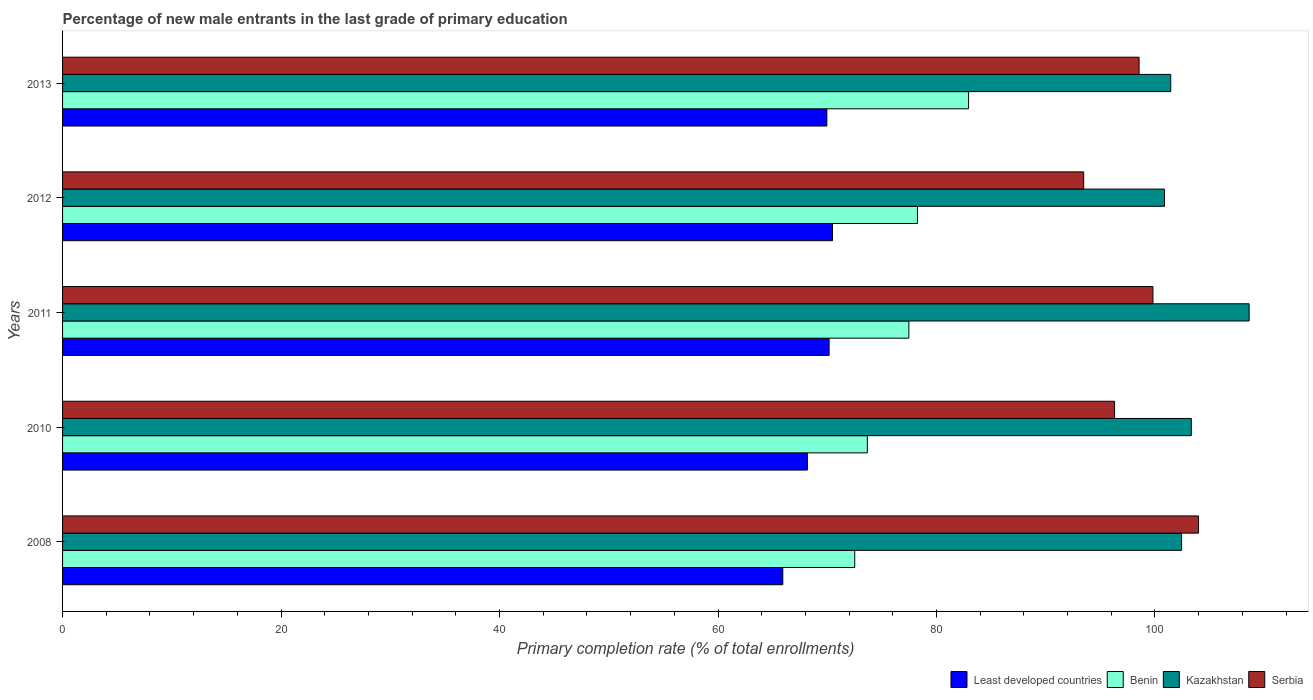Are the number of bars on each tick of the Y-axis equal?
Make the answer very short. Yes. What is the label of the 4th group of bars from the top?
Provide a succinct answer. 2010. What is the percentage of new male entrants in Kazakhstan in 2013?
Ensure brevity in your answer.  101.44. Across all years, what is the maximum percentage of new male entrants in Serbia?
Offer a very short reply. 103.99. Across all years, what is the minimum percentage of new male entrants in Kazakhstan?
Your answer should be very brief. 100.87. In which year was the percentage of new male entrants in Serbia minimum?
Keep it short and to the point. 2012. What is the total percentage of new male entrants in Least developed countries in the graph?
Ensure brevity in your answer.  344.72. What is the difference between the percentage of new male entrants in Kazakhstan in 2008 and that in 2013?
Offer a very short reply. 0.99. What is the difference between the percentage of new male entrants in Kazakhstan in 2010 and the percentage of new male entrants in Least developed countries in 2012?
Keep it short and to the point. 32.85. What is the average percentage of new male entrants in Kazakhstan per year?
Your response must be concise. 103.34. In the year 2011, what is the difference between the percentage of new male entrants in Kazakhstan and percentage of new male entrants in Benin?
Offer a terse response. 31.15. In how many years, is the percentage of new male entrants in Kazakhstan greater than 16 %?
Offer a very short reply. 5. What is the ratio of the percentage of new male entrants in Kazakhstan in 2010 to that in 2012?
Offer a very short reply. 1.02. Is the percentage of new male entrants in Benin in 2011 less than that in 2012?
Offer a terse response. Yes. Is the difference between the percentage of new male entrants in Kazakhstan in 2010 and 2012 greater than the difference between the percentage of new male entrants in Benin in 2010 and 2012?
Ensure brevity in your answer.  Yes. What is the difference between the highest and the second highest percentage of new male entrants in Serbia?
Offer a very short reply. 4.17. What is the difference between the highest and the lowest percentage of new male entrants in Serbia?
Ensure brevity in your answer.  10.51. What does the 3rd bar from the top in 2011 represents?
Provide a succinct answer. Benin. What does the 2nd bar from the bottom in 2010 represents?
Provide a succinct answer. Benin. Is it the case that in every year, the sum of the percentage of new male entrants in Benin and percentage of new male entrants in Kazakhstan is greater than the percentage of new male entrants in Serbia?
Make the answer very short. Yes. Are all the bars in the graph horizontal?
Keep it short and to the point. Yes. How many years are there in the graph?
Provide a short and direct response. 5. What is the difference between two consecutive major ticks on the X-axis?
Make the answer very short. 20. How many legend labels are there?
Your response must be concise. 4. What is the title of the graph?
Give a very brief answer. Percentage of new male entrants in the last grade of primary education. Does "Solomon Islands" appear as one of the legend labels in the graph?
Give a very brief answer. No. What is the label or title of the X-axis?
Your answer should be compact. Primary completion rate (% of total enrollments). What is the label or title of the Y-axis?
Give a very brief answer. Years. What is the Primary completion rate (% of total enrollments) of Least developed countries in 2008?
Your answer should be compact. 65.93. What is the Primary completion rate (% of total enrollments) of Benin in 2008?
Your response must be concise. 72.52. What is the Primary completion rate (% of total enrollments) of Kazakhstan in 2008?
Offer a terse response. 102.44. What is the Primary completion rate (% of total enrollments) of Serbia in 2008?
Provide a succinct answer. 103.99. What is the Primary completion rate (% of total enrollments) of Least developed countries in 2010?
Your answer should be compact. 68.18. What is the Primary completion rate (% of total enrollments) of Benin in 2010?
Your response must be concise. 73.67. What is the Primary completion rate (% of total enrollments) of Kazakhstan in 2010?
Offer a terse response. 103.33. What is the Primary completion rate (% of total enrollments) in Serbia in 2010?
Your response must be concise. 96.3. What is the Primary completion rate (% of total enrollments) in Least developed countries in 2011?
Your answer should be very brief. 70.17. What is the Primary completion rate (% of total enrollments) in Benin in 2011?
Ensure brevity in your answer.  77.47. What is the Primary completion rate (% of total enrollments) in Kazakhstan in 2011?
Offer a very short reply. 108.62. What is the Primary completion rate (% of total enrollments) of Serbia in 2011?
Offer a terse response. 99.81. What is the Primary completion rate (% of total enrollments) of Least developed countries in 2012?
Offer a terse response. 70.48. What is the Primary completion rate (% of total enrollments) in Benin in 2012?
Give a very brief answer. 78.26. What is the Primary completion rate (% of total enrollments) in Kazakhstan in 2012?
Ensure brevity in your answer.  100.87. What is the Primary completion rate (% of total enrollments) in Serbia in 2012?
Ensure brevity in your answer.  93.47. What is the Primary completion rate (% of total enrollments) in Least developed countries in 2013?
Offer a terse response. 69.96. What is the Primary completion rate (% of total enrollments) in Benin in 2013?
Your answer should be compact. 82.94. What is the Primary completion rate (% of total enrollments) of Kazakhstan in 2013?
Keep it short and to the point. 101.44. What is the Primary completion rate (% of total enrollments) in Serbia in 2013?
Give a very brief answer. 98.54. Across all years, what is the maximum Primary completion rate (% of total enrollments) of Least developed countries?
Ensure brevity in your answer.  70.48. Across all years, what is the maximum Primary completion rate (% of total enrollments) in Benin?
Give a very brief answer. 82.94. Across all years, what is the maximum Primary completion rate (% of total enrollments) in Kazakhstan?
Give a very brief answer. 108.62. Across all years, what is the maximum Primary completion rate (% of total enrollments) of Serbia?
Ensure brevity in your answer.  103.99. Across all years, what is the minimum Primary completion rate (% of total enrollments) of Least developed countries?
Your response must be concise. 65.93. Across all years, what is the minimum Primary completion rate (% of total enrollments) of Benin?
Provide a short and direct response. 72.52. Across all years, what is the minimum Primary completion rate (% of total enrollments) of Kazakhstan?
Your answer should be compact. 100.87. Across all years, what is the minimum Primary completion rate (% of total enrollments) in Serbia?
Your answer should be compact. 93.47. What is the total Primary completion rate (% of total enrollments) of Least developed countries in the graph?
Provide a succinct answer. 344.72. What is the total Primary completion rate (% of total enrollments) in Benin in the graph?
Ensure brevity in your answer.  384.85. What is the total Primary completion rate (% of total enrollments) of Kazakhstan in the graph?
Provide a succinct answer. 516.7. What is the total Primary completion rate (% of total enrollments) of Serbia in the graph?
Provide a succinct answer. 492.12. What is the difference between the Primary completion rate (% of total enrollments) of Least developed countries in 2008 and that in 2010?
Keep it short and to the point. -2.25. What is the difference between the Primary completion rate (% of total enrollments) in Benin in 2008 and that in 2010?
Provide a short and direct response. -1.15. What is the difference between the Primary completion rate (% of total enrollments) in Kazakhstan in 2008 and that in 2010?
Provide a succinct answer. -0.89. What is the difference between the Primary completion rate (% of total enrollments) in Serbia in 2008 and that in 2010?
Provide a succinct answer. 7.68. What is the difference between the Primary completion rate (% of total enrollments) of Least developed countries in 2008 and that in 2011?
Make the answer very short. -4.24. What is the difference between the Primary completion rate (% of total enrollments) of Benin in 2008 and that in 2011?
Your answer should be very brief. -4.96. What is the difference between the Primary completion rate (% of total enrollments) of Kazakhstan in 2008 and that in 2011?
Offer a terse response. -6.18. What is the difference between the Primary completion rate (% of total enrollments) in Serbia in 2008 and that in 2011?
Provide a short and direct response. 4.17. What is the difference between the Primary completion rate (% of total enrollments) of Least developed countries in 2008 and that in 2012?
Keep it short and to the point. -4.55. What is the difference between the Primary completion rate (% of total enrollments) of Benin in 2008 and that in 2012?
Offer a very short reply. -5.74. What is the difference between the Primary completion rate (% of total enrollments) in Kazakhstan in 2008 and that in 2012?
Your answer should be very brief. 1.56. What is the difference between the Primary completion rate (% of total enrollments) of Serbia in 2008 and that in 2012?
Provide a succinct answer. 10.51. What is the difference between the Primary completion rate (% of total enrollments) in Least developed countries in 2008 and that in 2013?
Keep it short and to the point. -4.03. What is the difference between the Primary completion rate (% of total enrollments) in Benin in 2008 and that in 2013?
Your answer should be very brief. -10.42. What is the difference between the Primary completion rate (% of total enrollments) in Kazakhstan in 2008 and that in 2013?
Make the answer very short. 0.99. What is the difference between the Primary completion rate (% of total enrollments) in Serbia in 2008 and that in 2013?
Give a very brief answer. 5.44. What is the difference between the Primary completion rate (% of total enrollments) in Least developed countries in 2010 and that in 2011?
Offer a very short reply. -1.99. What is the difference between the Primary completion rate (% of total enrollments) in Benin in 2010 and that in 2011?
Provide a succinct answer. -3.8. What is the difference between the Primary completion rate (% of total enrollments) in Kazakhstan in 2010 and that in 2011?
Make the answer very short. -5.29. What is the difference between the Primary completion rate (% of total enrollments) in Serbia in 2010 and that in 2011?
Keep it short and to the point. -3.51. What is the difference between the Primary completion rate (% of total enrollments) of Least developed countries in 2010 and that in 2012?
Make the answer very short. -2.3. What is the difference between the Primary completion rate (% of total enrollments) of Benin in 2010 and that in 2012?
Provide a succinct answer. -4.59. What is the difference between the Primary completion rate (% of total enrollments) in Kazakhstan in 2010 and that in 2012?
Make the answer very short. 2.46. What is the difference between the Primary completion rate (% of total enrollments) in Serbia in 2010 and that in 2012?
Provide a succinct answer. 2.83. What is the difference between the Primary completion rate (% of total enrollments) in Least developed countries in 2010 and that in 2013?
Provide a short and direct response. -1.78. What is the difference between the Primary completion rate (% of total enrollments) of Benin in 2010 and that in 2013?
Offer a terse response. -9.27. What is the difference between the Primary completion rate (% of total enrollments) of Kazakhstan in 2010 and that in 2013?
Your response must be concise. 1.88. What is the difference between the Primary completion rate (% of total enrollments) in Serbia in 2010 and that in 2013?
Offer a terse response. -2.24. What is the difference between the Primary completion rate (% of total enrollments) in Least developed countries in 2011 and that in 2012?
Keep it short and to the point. -0.31. What is the difference between the Primary completion rate (% of total enrollments) in Benin in 2011 and that in 2012?
Your response must be concise. -0.79. What is the difference between the Primary completion rate (% of total enrollments) in Kazakhstan in 2011 and that in 2012?
Offer a terse response. 7.75. What is the difference between the Primary completion rate (% of total enrollments) in Serbia in 2011 and that in 2012?
Ensure brevity in your answer.  6.34. What is the difference between the Primary completion rate (% of total enrollments) of Least developed countries in 2011 and that in 2013?
Keep it short and to the point. 0.21. What is the difference between the Primary completion rate (% of total enrollments) of Benin in 2011 and that in 2013?
Ensure brevity in your answer.  -5.46. What is the difference between the Primary completion rate (% of total enrollments) of Kazakhstan in 2011 and that in 2013?
Your response must be concise. 7.18. What is the difference between the Primary completion rate (% of total enrollments) in Serbia in 2011 and that in 2013?
Provide a short and direct response. 1.27. What is the difference between the Primary completion rate (% of total enrollments) in Least developed countries in 2012 and that in 2013?
Give a very brief answer. 0.52. What is the difference between the Primary completion rate (% of total enrollments) in Benin in 2012 and that in 2013?
Give a very brief answer. -4.68. What is the difference between the Primary completion rate (% of total enrollments) of Kazakhstan in 2012 and that in 2013?
Your response must be concise. -0.57. What is the difference between the Primary completion rate (% of total enrollments) of Serbia in 2012 and that in 2013?
Provide a short and direct response. -5.07. What is the difference between the Primary completion rate (% of total enrollments) in Least developed countries in 2008 and the Primary completion rate (% of total enrollments) in Benin in 2010?
Provide a short and direct response. -7.74. What is the difference between the Primary completion rate (% of total enrollments) in Least developed countries in 2008 and the Primary completion rate (% of total enrollments) in Kazakhstan in 2010?
Make the answer very short. -37.4. What is the difference between the Primary completion rate (% of total enrollments) of Least developed countries in 2008 and the Primary completion rate (% of total enrollments) of Serbia in 2010?
Your response must be concise. -30.37. What is the difference between the Primary completion rate (% of total enrollments) in Benin in 2008 and the Primary completion rate (% of total enrollments) in Kazakhstan in 2010?
Your answer should be compact. -30.81. What is the difference between the Primary completion rate (% of total enrollments) of Benin in 2008 and the Primary completion rate (% of total enrollments) of Serbia in 2010?
Make the answer very short. -23.79. What is the difference between the Primary completion rate (% of total enrollments) of Kazakhstan in 2008 and the Primary completion rate (% of total enrollments) of Serbia in 2010?
Ensure brevity in your answer.  6.13. What is the difference between the Primary completion rate (% of total enrollments) of Least developed countries in 2008 and the Primary completion rate (% of total enrollments) of Benin in 2011?
Give a very brief answer. -11.54. What is the difference between the Primary completion rate (% of total enrollments) in Least developed countries in 2008 and the Primary completion rate (% of total enrollments) in Kazakhstan in 2011?
Make the answer very short. -42.69. What is the difference between the Primary completion rate (% of total enrollments) of Least developed countries in 2008 and the Primary completion rate (% of total enrollments) of Serbia in 2011?
Provide a short and direct response. -33.88. What is the difference between the Primary completion rate (% of total enrollments) of Benin in 2008 and the Primary completion rate (% of total enrollments) of Kazakhstan in 2011?
Keep it short and to the point. -36.11. What is the difference between the Primary completion rate (% of total enrollments) of Benin in 2008 and the Primary completion rate (% of total enrollments) of Serbia in 2011?
Give a very brief answer. -27.3. What is the difference between the Primary completion rate (% of total enrollments) of Kazakhstan in 2008 and the Primary completion rate (% of total enrollments) of Serbia in 2011?
Provide a succinct answer. 2.62. What is the difference between the Primary completion rate (% of total enrollments) of Least developed countries in 2008 and the Primary completion rate (% of total enrollments) of Benin in 2012?
Your answer should be very brief. -12.33. What is the difference between the Primary completion rate (% of total enrollments) of Least developed countries in 2008 and the Primary completion rate (% of total enrollments) of Kazakhstan in 2012?
Provide a short and direct response. -34.94. What is the difference between the Primary completion rate (% of total enrollments) of Least developed countries in 2008 and the Primary completion rate (% of total enrollments) of Serbia in 2012?
Your answer should be compact. -27.54. What is the difference between the Primary completion rate (% of total enrollments) in Benin in 2008 and the Primary completion rate (% of total enrollments) in Kazakhstan in 2012?
Make the answer very short. -28.36. What is the difference between the Primary completion rate (% of total enrollments) in Benin in 2008 and the Primary completion rate (% of total enrollments) in Serbia in 2012?
Offer a terse response. -20.96. What is the difference between the Primary completion rate (% of total enrollments) of Kazakhstan in 2008 and the Primary completion rate (% of total enrollments) of Serbia in 2012?
Give a very brief answer. 8.96. What is the difference between the Primary completion rate (% of total enrollments) in Least developed countries in 2008 and the Primary completion rate (% of total enrollments) in Benin in 2013?
Your answer should be compact. -17.01. What is the difference between the Primary completion rate (% of total enrollments) in Least developed countries in 2008 and the Primary completion rate (% of total enrollments) in Kazakhstan in 2013?
Provide a succinct answer. -35.51. What is the difference between the Primary completion rate (% of total enrollments) in Least developed countries in 2008 and the Primary completion rate (% of total enrollments) in Serbia in 2013?
Offer a terse response. -32.61. What is the difference between the Primary completion rate (% of total enrollments) of Benin in 2008 and the Primary completion rate (% of total enrollments) of Kazakhstan in 2013?
Your response must be concise. -28.93. What is the difference between the Primary completion rate (% of total enrollments) of Benin in 2008 and the Primary completion rate (% of total enrollments) of Serbia in 2013?
Your answer should be compact. -26.03. What is the difference between the Primary completion rate (% of total enrollments) in Kazakhstan in 2008 and the Primary completion rate (% of total enrollments) in Serbia in 2013?
Your response must be concise. 3.89. What is the difference between the Primary completion rate (% of total enrollments) of Least developed countries in 2010 and the Primary completion rate (% of total enrollments) of Benin in 2011?
Provide a succinct answer. -9.29. What is the difference between the Primary completion rate (% of total enrollments) in Least developed countries in 2010 and the Primary completion rate (% of total enrollments) in Kazakhstan in 2011?
Offer a terse response. -40.44. What is the difference between the Primary completion rate (% of total enrollments) of Least developed countries in 2010 and the Primary completion rate (% of total enrollments) of Serbia in 2011?
Provide a short and direct response. -31.63. What is the difference between the Primary completion rate (% of total enrollments) in Benin in 2010 and the Primary completion rate (% of total enrollments) in Kazakhstan in 2011?
Your answer should be compact. -34.95. What is the difference between the Primary completion rate (% of total enrollments) of Benin in 2010 and the Primary completion rate (% of total enrollments) of Serbia in 2011?
Your answer should be compact. -26.14. What is the difference between the Primary completion rate (% of total enrollments) of Kazakhstan in 2010 and the Primary completion rate (% of total enrollments) of Serbia in 2011?
Keep it short and to the point. 3.52. What is the difference between the Primary completion rate (% of total enrollments) of Least developed countries in 2010 and the Primary completion rate (% of total enrollments) of Benin in 2012?
Give a very brief answer. -10.08. What is the difference between the Primary completion rate (% of total enrollments) in Least developed countries in 2010 and the Primary completion rate (% of total enrollments) in Kazakhstan in 2012?
Your answer should be very brief. -32.69. What is the difference between the Primary completion rate (% of total enrollments) of Least developed countries in 2010 and the Primary completion rate (% of total enrollments) of Serbia in 2012?
Your answer should be compact. -25.29. What is the difference between the Primary completion rate (% of total enrollments) in Benin in 2010 and the Primary completion rate (% of total enrollments) in Kazakhstan in 2012?
Keep it short and to the point. -27.2. What is the difference between the Primary completion rate (% of total enrollments) in Benin in 2010 and the Primary completion rate (% of total enrollments) in Serbia in 2012?
Your response must be concise. -19.8. What is the difference between the Primary completion rate (% of total enrollments) of Kazakhstan in 2010 and the Primary completion rate (% of total enrollments) of Serbia in 2012?
Your answer should be compact. 9.86. What is the difference between the Primary completion rate (% of total enrollments) of Least developed countries in 2010 and the Primary completion rate (% of total enrollments) of Benin in 2013?
Offer a very short reply. -14.76. What is the difference between the Primary completion rate (% of total enrollments) of Least developed countries in 2010 and the Primary completion rate (% of total enrollments) of Kazakhstan in 2013?
Keep it short and to the point. -33.26. What is the difference between the Primary completion rate (% of total enrollments) of Least developed countries in 2010 and the Primary completion rate (% of total enrollments) of Serbia in 2013?
Your answer should be compact. -30.36. What is the difference between the Primary completion rate (% of total enrollments) of Benin in 2010 and the Primary completion rate (% of total enrollments) of Kazakhstan in 2013?
Provide a succinct answer. -27.78. What is the difference between the Primary completion rate (% of total enrollments) of Benin in 2010 and the Primary completion rate (% of total enrollments) of Serbia in 2013?
Offer a very short reply. -24.88. What is the difference between the Primary completion rate (% of total enrollments) of Kazakhstan in 2010 and the Primary completion rate (% of total enrollments) of Serbia in 2013?
Keep it short and to the point. 4.78. What is the difference between the Primary completion rate (% of total enrollments) in Least developed countries in 2011 and the Primary completion rate (% of total enrollments) in Benin in 2012?
Your response must be concise. -8.09. What is the difference between the Primary completion rate (% of total enrollments) of Least developed countries in 2011 and the Primary completion rate (% of total enrollments) of Kazakhstan in 2012?
Your response must be concise. -30.7. What is the difference between the Primary completion rate (% of total enrollments) in Least developed countries in 2011 and the Primary completion rate (% of total enrollments) in Serbia in 2012?
Your answer should be very brief. -23.3. What is the difference between the Primary completion rate (% of total enrollments) of Benin in 2011 and the Primary completion rate (% of total enrollments) of Kazakhstan in 2012?
Give a very brief answer. -23.4. What is the difference between the Primary completion rate (% of total enrollments) of Benin in 2011 and the Primary completion rate (% of total enrollments) of Serbia in 2012?
Your answer should be very brief. -16. What is the difference between the Primary completion rate (% of total enrollments) of Kazakhstan in 2011 and the Primary completion rate (% of total enrollments) of Serbia in 2012?
Your answer should be very brief. 15.15. What is the difference between the Primary completion rate (% of total enrollments) in Least developed countries in 2011 and the Primary completion rate (% of total enrollments) in Benin in 2013?
Offer a terse response. -12.77. What is the difference between the Primary completion rate (% of total enrollments) in Least developed countries in 2011 and the Primary completion rate (% of total enrollments) in Kazakhstan in 2013?
Your response must be concise. -31.27. What is the difference between the Primary completion rate (% of total enrollments) in Least developed countries in 2011 and the Primary completion rate (% of total enrollments) in Serbia in 2013?
Provide a short and direct response. -28.38. What is the difference between the Primary completion rate (% of total enrollments) in Benin in 2011 and the Primary completion rate (% of total enrollments) in Kazakhstan in 2013?
Offer a very short reply. -23.97. What is the difference between the Primary completion rate (% of total enrollments) in Benin in 2011 and the Primary completion rate (% of total enrollments) in Serbia in 2013?
Make the answer very short. -21.07. What is the difference between the Primary completion rate (% of total enrollments) in Kazakhstan in 2011 and the Primary completion rate (% of total enrollments) in Serbia in 2013?
Offer a very short reply. 10.08. What is the difference between the Primary completion rate (% of total enrollments) in Least developed countries in 2012 and the Primary completion rate (% of total enrollments) in Benin in 2013?
Your answer should be very brief. -12.45. What is the difference between the Primary completion rate (% of total enrollments) in Least developed countries in 2012 and the Primary completion rate (% of total enrollments) in Kazakhstan in 2013?
Provide a short and direct response. -30.96. What is the difference between the Primary completion rate (% of total enrollments) in Least developed countries in 2012 and the Primary completion rate (% of total enrollments) in Serbia in 2013?
Provide a short and direct response. -28.06. What is the difference between the Primary completion rate (% of total enrollments) of Benin in 2012 and the Primary completion rate (% of total enrollments) of Kazakhstan in 2013?
Keep it short and to the point. -23.19. What is the difference between the Primary completion rate (% of total enrollments) of Benin in 2012 and the Primary completion rate (% of total enrollments) of Serbia in 2013?
Make the answer very short. -20.29. What is the difference between the Primary completion rate (% of total enrollments) in Kazakhstan in 2012 and the Primary completion rate (% of total enrollments) in Serbia in 2013?
Your response must be concise. 2.33. What is the average Primary completion rate (% of total enrollments) of Least developed countries per year?
Give a very brief answer. 68.94. What is the average Primary completion rate (% of total enrollments) of Benin per year?
Ensure brevity in your answer.  76.97. What is the average Primary completion rate (% of total enrollments) of Kazakhstan per year?
Ensure brevity in your answer.  103.34. What is the average Primary completion rate (% of total enrollments) in Serbia per year?
Your answer should be very brief. 98.42. In the year 2008, what is the difference between the Primary completion rate (% of total enrollments) in Least developed countries and Primary completion rate (% of total enrollments) in Benin?
Ensure brevity in your answer.  -6.59. In the year 2008, what is the difference between the Primary completion rate (% of total enrollments) of Least developed countries and Primary completion rate (% of total enrollments) of Kazakhstan?
Provide a short and direct response. -36.51. In the year 2008, what is the difference between the Primary completion rate (% of total enrollments) in Least developed countries and Primary completion rate (% of total enrollments) in Serbia?
Your answer should be compact. -38.06. In the year 2008, what is the difference between the Primary completion rate (% of total enrollments) in Benin and Primary completion rate (% of total enrollments) in Kazakhstan?
Your answer should be compact. -29.92. In the year 2008, what is the difference between the Primary completion rate (% of total enrollments) of Benin and Primary completion rate (% of total enrollments) of Serbia?
Provide a succinct answer. -31.47. In the year 2008, what is the difference between the Primary completion rate (% of total enrollments) of Kazakhstan and Primary completion rate (% of total enrollments) of Serbia?
Provide a short and direct response. -1.55. In the year 2010, what is the difference between the Primary completion rate (% of total enrollments) in Least developed countries and Primary completion rate (% of total enrollments) in Benin?
Ensure brevity in your answer.  -5.49. In the year 2010, what is the difference between the Primary completion rate (% of total enrollments) in Least developed countries and Primary completion rate (% of total enrollments) in Kazakhstan?
Keep it short and to the point. -35.15. In the year 2010, what is the difference between the Primary completion rate (% of total enrollments) of Least developed countries and Primary completion rate (% of total enrollments) of Serbia?
Your answer should be compact. -28.12. In the year 2010, what is the difference between the Primary completion rate (% of total enrollments) in Benin and Primary completion rate (% of total enrollments) in Kazakhstan?
Provide a succinct answer. -29.66. In the year 2010, what is the difference between the Primary completion rate (% of total enrollments) of Benin and Primary completion rate (% of total enrollments) of Serbia?
Ensure brevity in your answer.  -22.63. In the year 2010, what is the difference between the Primary completion rate (% of total enrollments) of Kazakhstan and Primary completion rate (% of total enrollments) of Serbia?
Offer a terse response. 7.03. In the year 2011, what is the difference between the Primary completion rate (% of total enrollments) in Least developed countries and Primary completion rate (% of total enrollments) in Benin?
Offer a terse response. -7.3. In the year 2011, what is the difference between the Primary completion rate (% of total enrollments) of Least developed countries and Primary completion rate (% of total enrollments) of Kazakhstan?
Provide a succinct answer. -38.45. In the year 2011, what is the difference between the Primary completion rate (% of total enrollments) in Least developed countries and Primary completion rate (% of total enrollments) in Serbia?
Make the answer very short. -29.64. In the year 2011, what is the difference between the Primary completion rate (% of total enrollments) in Benin and Primary completion rate (% of total enrollments) in Kazakhstan?
Give a very brief answer. -31.15. In the year 2011, what is the difference between the Primary completion rate (% of total enrollments) of Benin and Primary completion rate (% of total enrollments) of Serbia?
Offer a terse response. -22.34. In the year 2011, what is the difference between the Primary completion rate (% of total enrollments) in Kazakhstan and Primary completion rate (% of total enrollments) in Serbia?
Provide a succinct answer. 8.81. In the year 2012, what is the difference between the Primary completion rate (% of total enrollments) in Least developed countries and Primary completion rate (% of total enrollments) in Benin?
Make the answer very short. -7.78. In the year 2012, what is the difference between the Primary completion rate (% of total enrollments) in Least developed countries and Primary completion rate (% of total enrollments) in Kazakhstan?
Your response must be concise. -30.39. In the year 2012, what is the difference between the Primary completion rate (% of total enrollments) of Least developed countries and Primary completion rate (% of total enrollments) of Serbia?
Make the answer very short. -22.99. In the year 2012, what is the difference between the Primary completion rate (% of total enrollments) in Benin and Primary completion rate (% of total enrollments) in Kazakhstan?
Your answer should be very brief. -22.62. In the year 2012, what is the difference between the Primary completion rate (% of total enrollments) in Benin and Primary completion rate (% of total enrollments) in Serbia?
Provide a short and direct response. -15.21. In the year 2012, what is the difference between the Primary completion rate (% of total enrollments) of Kazakhstan and Primary completion rate (% of total enrollments) of Serbia?
Give a very brief answer. 7.4. In the year 2013, what is the difference between the Primary completion rate (% of total enrollments) in Least developed countries and Primary completion rate (% of total enrollments) in Benin?
Ensure brevity in your answer.  -12.97. In the year 2013, what is the difference between the Primary completion rate (% of total enrollments) in Least developed countries and Primary completion rate (% of total enrollments) in Kazakhstan?
Provide a short and direct response. -31.48. In the year 2013, what is the difference between the Primary completion rate (% of total enrollments) in Least developed countries and Primary completion rate (% of total enrollments) in Serbia?
Offer a very short reply. -28.58. In the year 2013, what is the difference between the Primary completion rate (% of total enrollments) in Benin and Primary completion rate (% of total enrollments) in Kazakhstan?
Ensure brevity in your answer.  -18.51. In the year 2013, what is the difference between the Primary completion rate (% of total enrollments) in Benin and Primary completion rate (% of total enrollments) in Serbia?
Keep it short and to the point. -15.61. In the year 2013, what is the difference between the Primary completion rate (% of total enrollments) in Kazakhstan and Primary completion rate (% of total enrollments) in Serbia?
Make the answer very short. 2.9. What is the ratio of the Primary completion rate (% of total enrollments) in Least developed countries in 2008 to that in 2010?
Your answer should be very brief. 0.97. What is the ratio of the Primary completion rate (% of total enrollments) in Benin in 2008 to that in 2010?
Ensure brevity in your answer.  0.98. What is the ratio of the Primary completion rate (% of total enrollments) of Serbia in 2008 to that in 2010?
Offer a very short reply. 1.08. What is the ratio of the Primary completion rate (% of total enrollments) in Least developed countries in 2008 to that in 2011?
Your answer should be very brief. 0.94. What is the ratio of the Primary completion rate (% of total enrollments) in Benin in 2008 to that in 2011?
Ensure brevity in your answer.  0.94. What is the ratio of the Primary completion rate (% of total enrollments) of Kazakhstan in 2008 to that in 2011?
Keep it short and to the point. 0.94. What is the ratio of the Primary completion rate (% of total enrollments) in Serbia in 2008 to that in 2011?
Make the answer very short. 1.04. What is the ratio of the Primary completion rate (% of total enrollments) in Least developed countries in 2008 to that in 2012?
Provide a short and direct response. 0.94. What is the ratio of the Primary completion rate (% of total enrollments) in Benin in 2008 to that in 2012?
Offer a terse response. 0.93. What is the ratio of the Primary completion rate (% of total enrollments) of Kazakhstan in 2008 to that in 2012?
Your response must be concise. 1.02. What is the ratio of the Primary completion rate (% of total enrollments) of Serbia in 2008 to that in 2012?
Give a very brief answer. 1.11. What is the ratio of the Primary completion rate (% of total enrollments) in Least developed countries in 2008 to that in 2013?
Your response must be concise. 0.94. What is the ratio of the Primary completion rate (% of total enrollments) of Benin in 2008 to that in 2013?
Offer a terse response. 0.87. What is the ratio of the Primary completion rate (% of total enrollments) of Kazakhstan in 2008 to that in 2013?
Provide a short and direct response. 1.01. What is the ratio of the Primary completion rate (% of total enrollments) of Serbia in 2008 to that in 2013?
Offer a terse response. 1.06. What is the ratio of the Primary completion rate (% of total enrollments) of Least developed countries in 2010 to that in 2011?
Make the answer very short. 0.97. What is the ratio of the Primary completion rate (% of total enrollments) of Benin in 2010 to that in 2011?
Offer a very short reply. 0.95. What is the ratio of the Primary completion rate (% of total enrollments) of Kazakhstan in 2010 to that in 2011?
Provide a succinct answer. 0.95. What is the ratio of the Primary completion rate (% of total enrollments) in Serbia in 2010 to that in 2011?
Provide a short and direct response. 0.96. What is the ratio of the Primary completion rate (% of total enrollments) in Least developed countries in 2010 to that in 2012?
Your answer should be compact. 0.97. What is the ratio of the Primary completion rate (% of total enrollments) in Benin in 2010 to that in 2012?
Keep it short and to the point. 0.94. What is the ratio of the Primary completion rate (% of total enrollments) of Kazakhstan in 2010 to that in 2012?
Keep it short and to the point. 1.02. What is the ratio of the Primary completion rate (% of total enrollments) in Serbia in 2010 to that in 2012?
Keep it short and to the point. 1.03. What is the ratio of the Primary completion rate (% of total enrollments) in Least developed countries in 2010 to that in 2013?
Offer a very short reply. 0.97. What is the ratio of the Primary completion rate (% of total enrollments) of Benin in 2010 to that in 2013?
Give a very brief answer. 0.89. What is the ratio of the Primary completion rate (% of total enrollments) in Kazakhstan in 2010 to that in 2013?
Make the answer very short. 1.02. What is the ratio of the Primary completion rate (% of total enrollments) of Serbia in 2010 to that in 2013?
Make the answer very short. 0.98. What is the ratio of the Primary completion rate (% of total enrollments) in Least developed countries in 2011 to that in 2012?
Your response must be concise. 1. What is the ratio of the Primary completion rate (% of total enrollments) of Benin in 2011 to that in 2012?
Your answer should be very brief. 0.99. What is the ratio of the Primary completion rate (% of total enrollments) of Kazakhstan in 2011 to that in 2012?
Make the answer very short. 1.08. What is the ratio of the Primary completion rate (% of total enrollments) of Serbia in 2011 to that in 2012?
Provide a succinct answer. 1.07. What is the ratio of the Primary completion rate (% of total enrollments) of Least developed countries in 2011 to that in 2013?
Your answer should be very brief. 1. What is the ratio of the Primary completion rate (% of total enrollments) in Benin in 2011 to that in 2013?
Make the answer very short. 0.93. What is the ratio of the Primary completion rate (% of total enrollments) in Kazakhstan in 2011 to that in 2013?
Provide a succinct answer. 1.07. What is the ratio of the Primary completion rate (% of total enrollments) in Serbia in 2011 to that in 2013?
Offer a terse response. 1.01. What is the ratio of the Primary completion rate (% of total enrollments) in Least developed countries in 2012 to that in 2013?
Ensure brevity in your answer.  1.01. What is the ratio of the Primary completion rate (% of total enrollments) in Benin in 2012 to that in 2013?
Your answer should be very brief. 0.94. What is the ratio of the Primary completion rate (% of total enrollments) of Serbia in 2012 to that in 2013?
Your answer should be very brief. 0.95. What is the difference between the highest and the second highest Primary completion rate (% of total enrollments) of Least developed countries?
Provide a short and direct response. 0.31. What is the difference between the highest and the second highest Primary completion rate (% of total enrollments) in Benin?
Offer a very short reply. 4.68. What is the difference between the highest and the second highest Primary completion rate (% of total enrollments) of Kazakhstan?
Give a very brief answer. 5.29. What is the difference between the highest and the second highest Primary completion rate (% of total enrollments) in Serbia?
Provide a succinct answer. 4.17. What is the difference between the highest and the lowest Primary completion rate (% of total enrollments) in Least developed countries?
Ensure brevity in your answer.  4.55. What is the difference between the highest and the lowest Primary completion rate (% of total enrollments) of Benin?
Your answer should be very brief. 10.42. What is the difference between the highest and the lowest Primary completion rate (% of total enrollments) of Kazakhstan?
Ensure brevity in your answer.  7.75. What is the difference between the highest and the lowest Primary completion rate (% of total enrollments) of Serbia?
Your response must be concise. 10.51. 